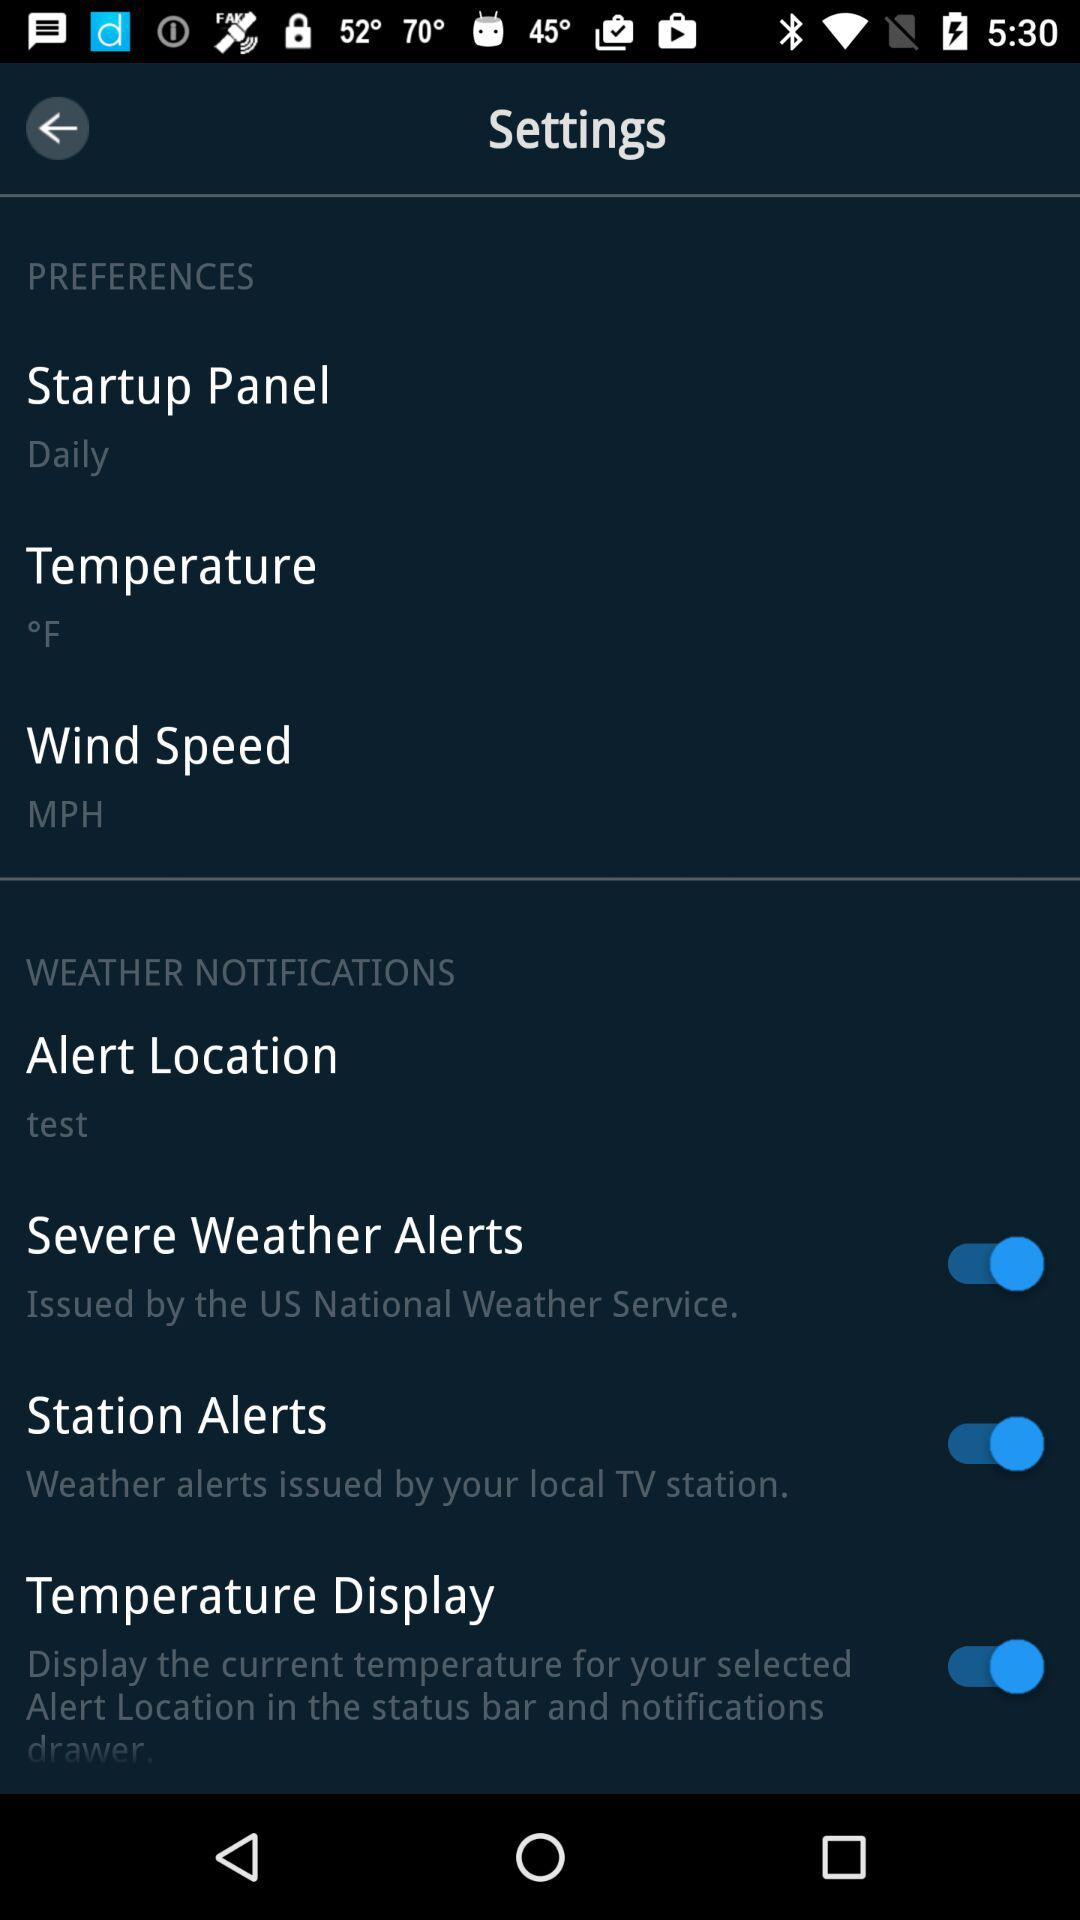What is the status of "Station Alerts"? The status is "on". 